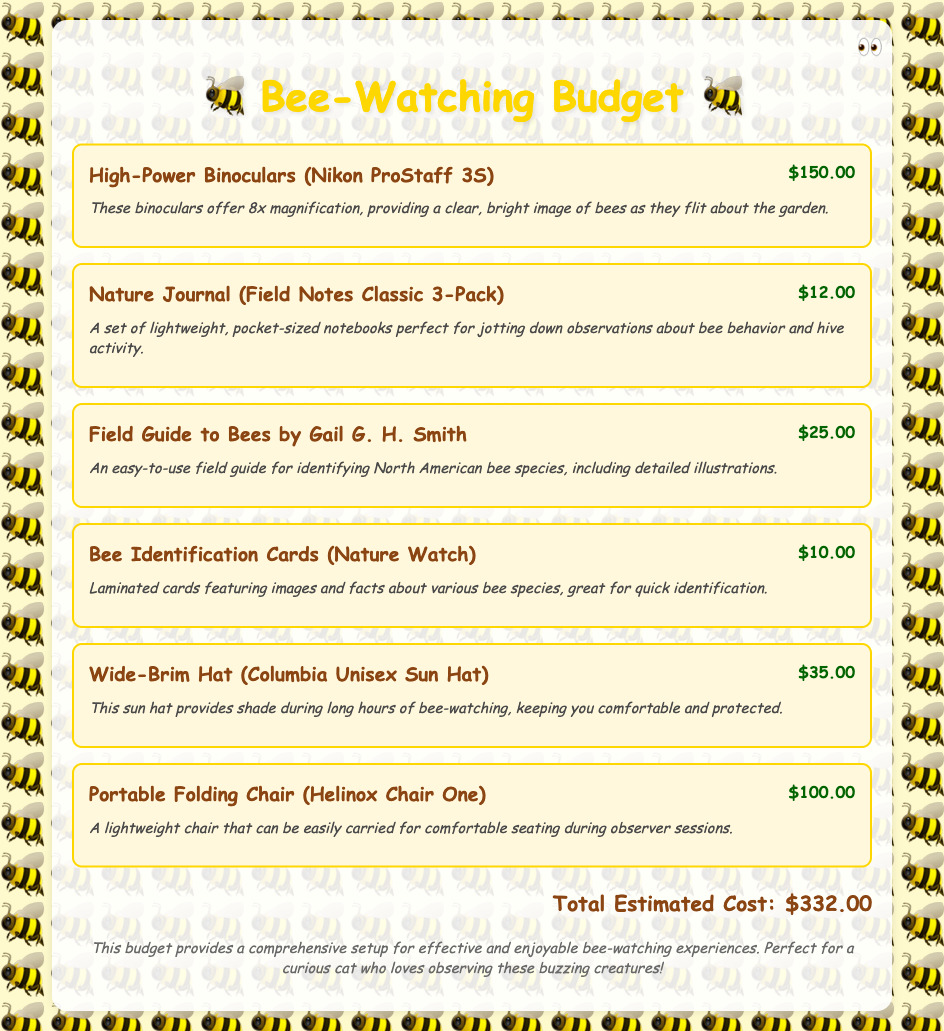What is the total estimated cost? The total estimated cost is presented at the bottom of the document, summing all the individual expenses listed.
Answer: $332.00 How much do the high-power binoculars cost? The cost of the high-power binoculars is specifically noted in the budget item description.
Answer: $150.00 What is the purpose of the nature journal? The document describes the nature journal as being perfect for jotting down observations about bee behavior and hive activity.
Answer: Jotting down observations How many items are listed in the budget? The budget lists each item individually, and counting them gives the total number of items.
Answer: 6 Who is the author of the field guide to bees? The document provides the name of the author in the budget item for the field guide.
Answer: Gail G. H. Smith What type of chair is included in the budget? The specific type of chair is mentioned in the item's description, providing essential details about the product.
Answer: Portable Folding Chair How many notebooks are included in the nature journal pack? The document states the number of notebooks included in the nature journal pack clearly in its description.
Answer: 3-Pack What item provides shade during bee-watching? The document indicates the specific item that helps with sun protection during bee-watching activities.
Answer: Wide-Brim Hat What is the item description for the bee identification cards? The bee identification cards' description mentions their features and purpose for the user.
Answer: Laminated cards featuring images and facts 